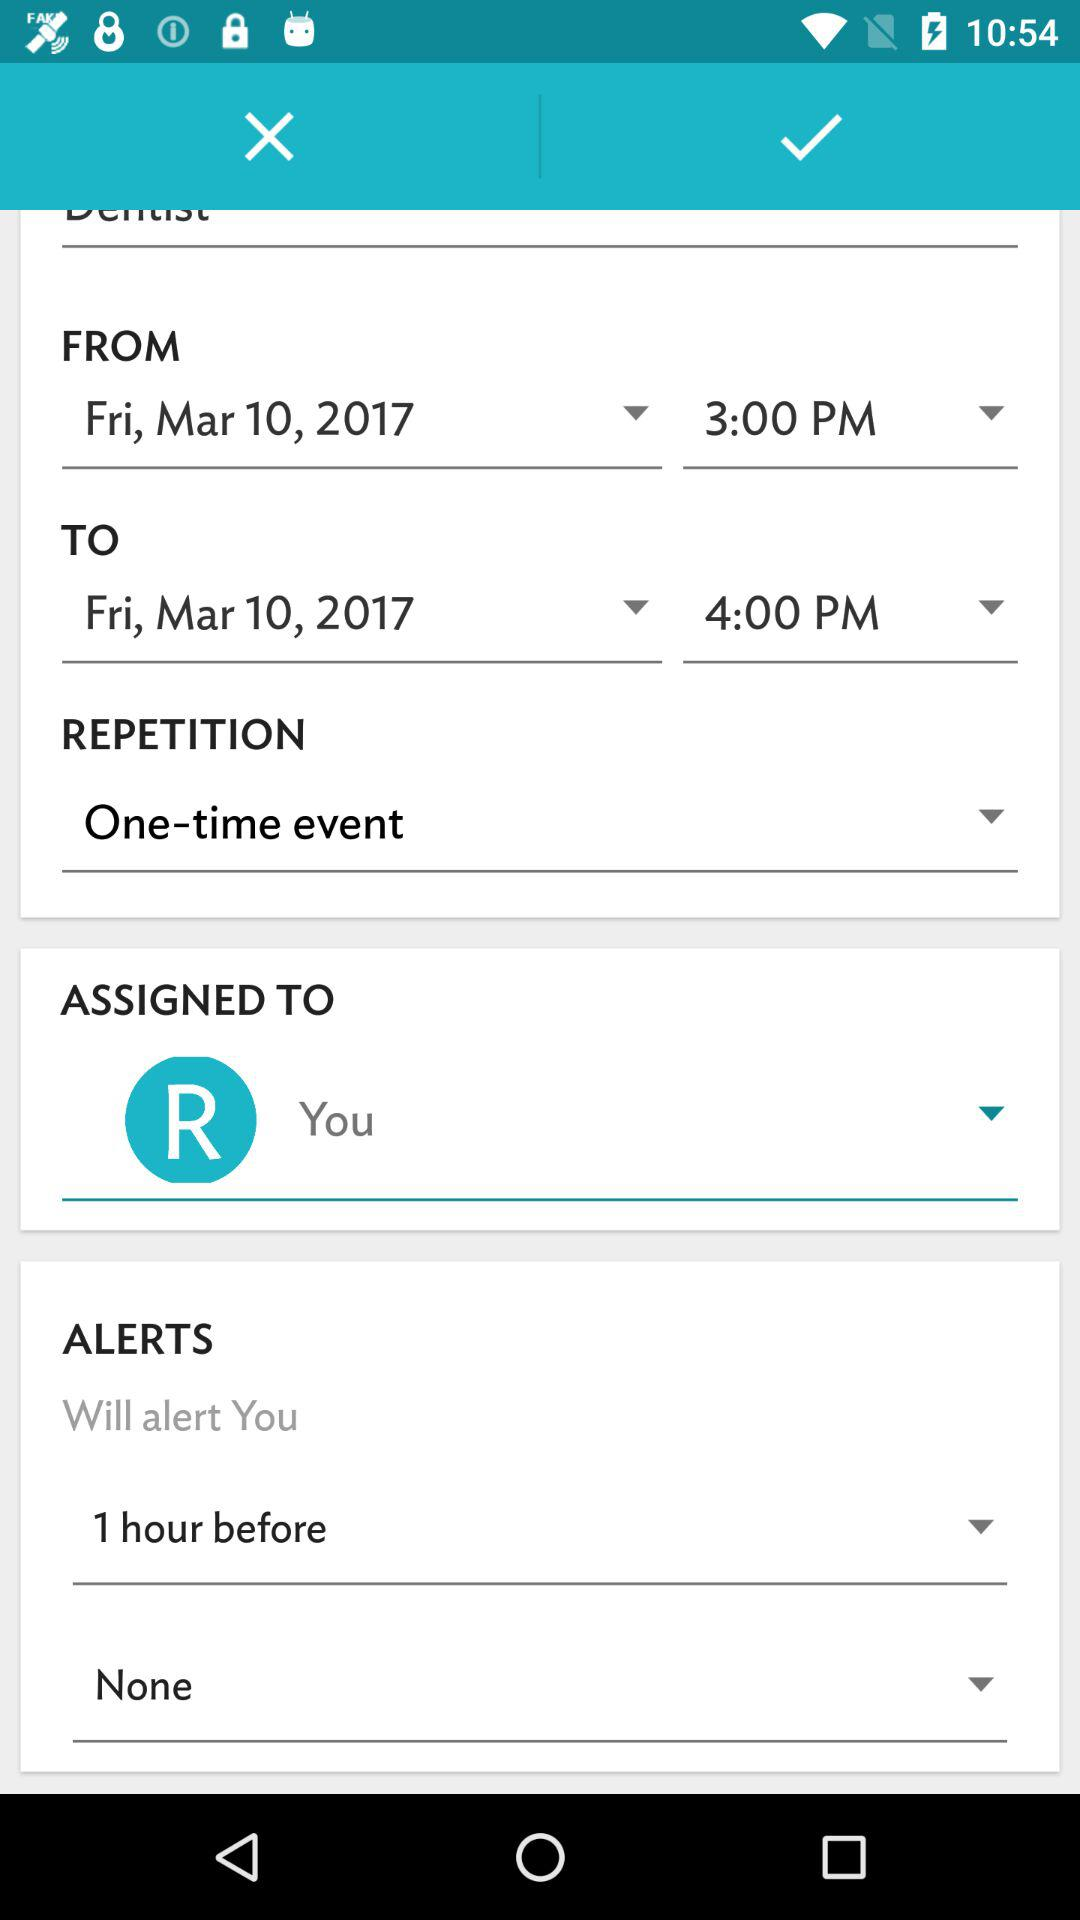What is the difference between the start and end times of the event?
Answer the question using a single word or phrase. 1 hour 